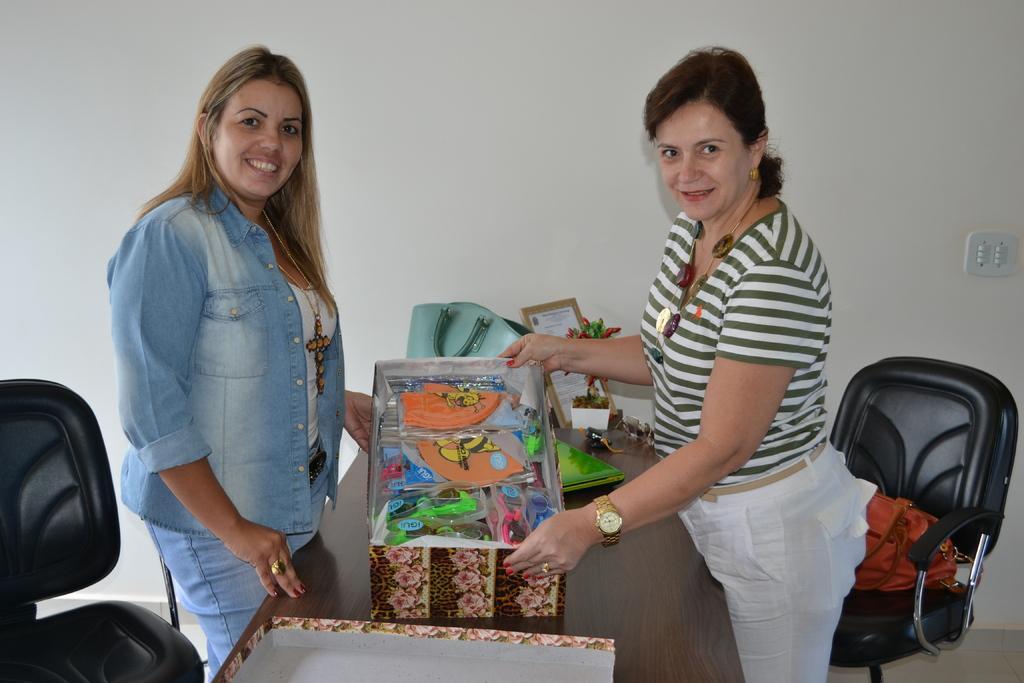Could you give a brief overview of what you see in this image? This is a picture taken in a room, there are two women standing on a floor in front of this women there is a table on the table there is a toys with boxes and a bag. Background of this people is a white wall. To the women's right, left and right side there are the chairs. 